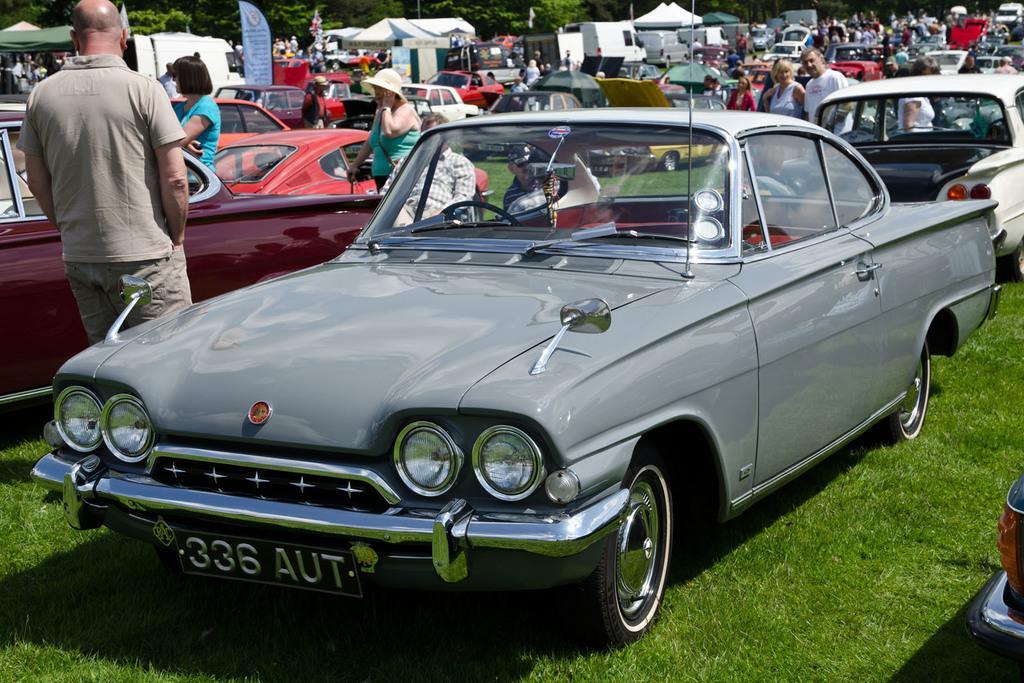How would you summarize this image in a sentence or two? In this picture we can see a car on the ground ,and a person standing beside the car, and there are group of people standing, and at back there are trees at back side. 